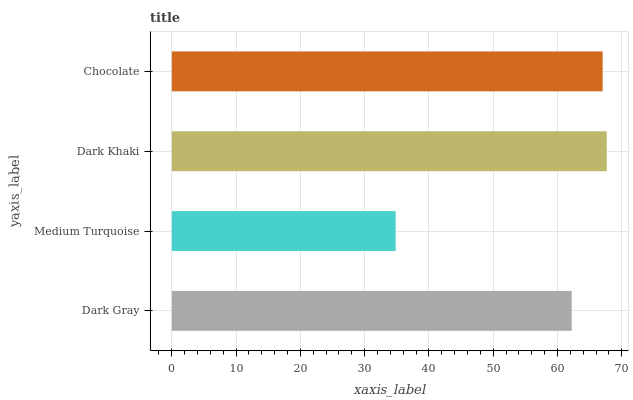Is Medium Turquoise the minimum?
Answer yes or no. Yes. Is Dark Khaki the maximum?
Answer yes or no. Yes. Is Dark Khaki the minimum?
Answer yes or no. No. Is Medium Turquoise the maximum?
Answer yes or no. No. Is Dark Khaki greater than Medium Turquoise?
Answer yes or no. Yes. Is Medium Turquoise less than Dark Khaki?
Answer yes or no. Yes. Is Medium Turquoise greater than Dark Khaki?
Answer yes or no. No. Is Dark Khaki less than Medium Turquoise?
Answer yes or no. No. Is Chocolate the high median?
Answer yes or no. Yes. Is Dark Gray the low median?
Answer yes or no. Yes. Is Dark Khaki the high median?
Answer yes or no. No. Is Dark Khaki the low median?
Answer yes or no. No. 